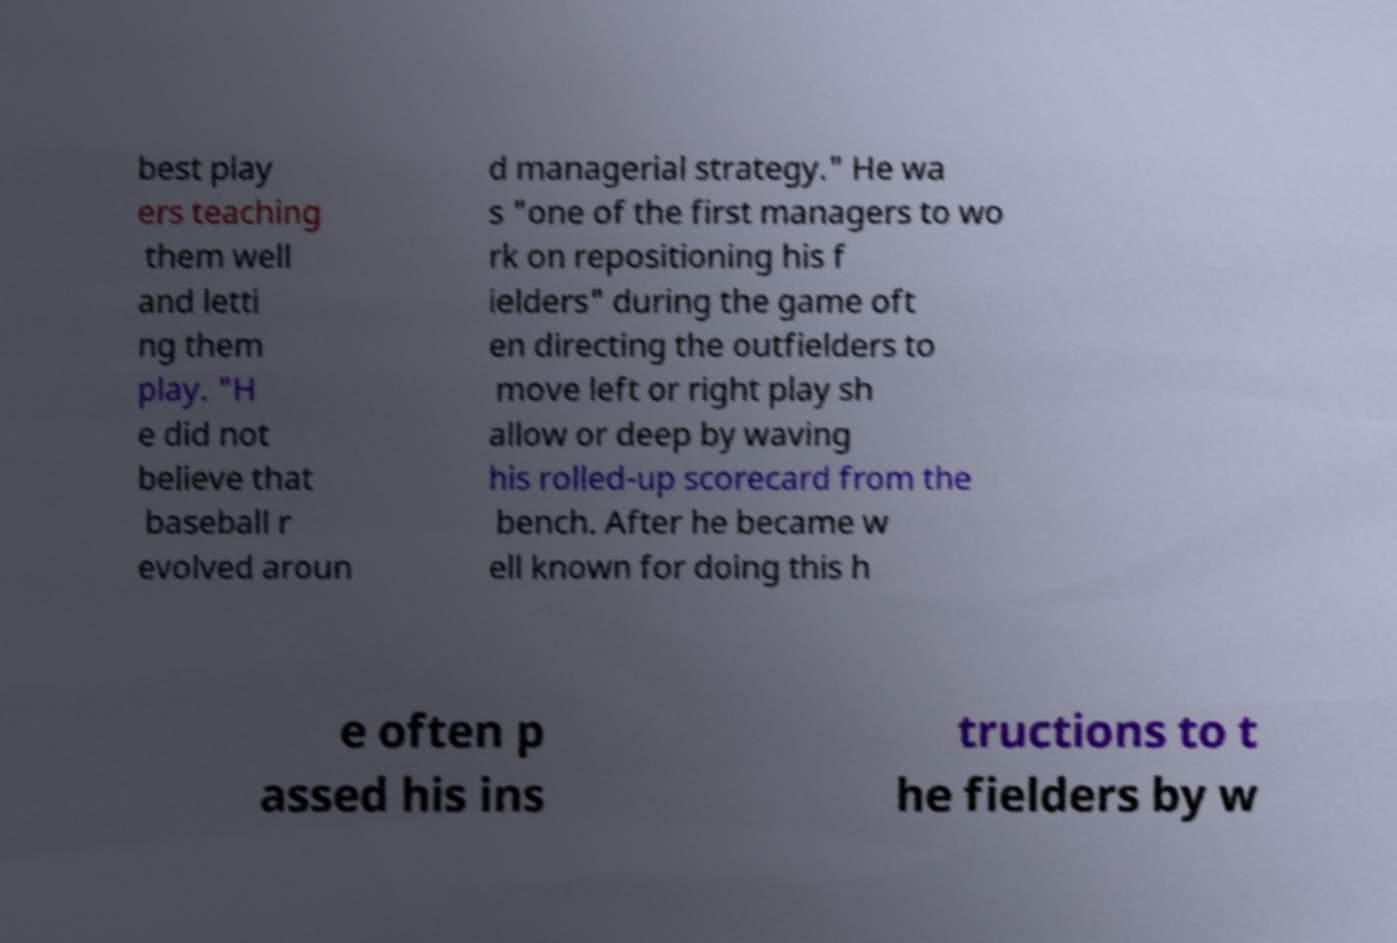Could you extract and type out the text from this image? best play ers teaching them well and letti ng them play. "H e did not believe that baseball r evolved aroun d managerial strategy." He wa s "one of the first managers to wo rk on repositioning his f ielders" during the game oft en directing the outfielders to move left or right play sh allow or deep by waving his rolled-up scorecard from the bench. After he became w ell known for doing this h e often p assed his ins tructions to t he fielders by w 